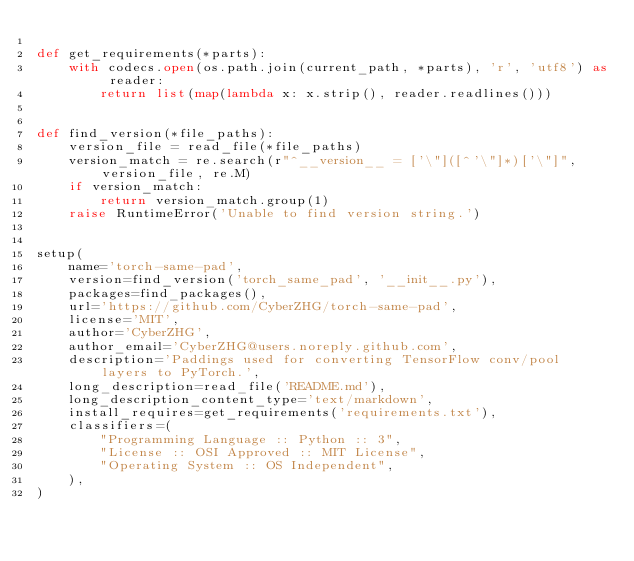<code> <loc_0><loc_0><loc_500><loc_500><_Python_>
def get_requirements(*parts):
    with codecs.open(os.path.join(current_path, *parts), 'r', 'utf8') as reader:
        return list(map(lambda x: x.strip(), reader.readlines()))


def find_version(*file_paths):
    version_file = read_file(*file_paths)
    version_match = re.search(r"^__version__ = ['\"]([^'\"]*)['\"]", version_file, re.M)
    if version_match:
        return version_match.group(1)
    raise RuntimeError('Unable to find version string.')


setup(
    name='torch-same-pad',
    version=find_version('torch_same_pad', '__init__.py'),
    packages=find_packages(),
    url='https://github.com/CyberZHG/torch-same-pad',
    license='MIT',
    author='CyberZHG',
    author_email='CyberZHG@users.noreply.github.com',
    description='Paddings used for converting TensorFlow conv/pool layers to PyTorch.',
    long_description=read_file('README.md'),
    long_description_content_type='text/markdown',
    install_requires=get_requirements('requirements.txt'),
    classifiers=(
        "Programming Language :: Python :: 3",
        "License :: OSI Approved :: MIT License",
        "Operating System :: OS Independent",
    ),
)
</code> 